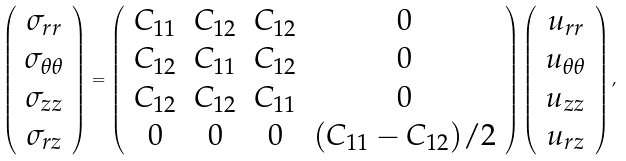<formula> <loc_0><loc_0><loc_500><loc_500>\left ( \begin{array} { c } \sigma _ { r r } \\ \sigma _ { \theta \theta } \\ \sigma _ { z z } \\ \sigma _ { r z } \\ \end{array} \right ) = \left ( \begin{array} { c c c c } C _ { 1 1 } & C _ { 1 2 } & C _ { 1 2 } & 0 \\ C _ { 1 2 } & C _ { 1 1 } & C _ { 1 2 } & 0 \\ C _ { 1 2 } & C _ { 1 2 } & C _ { 1 1 } & 0 \\ 0 & 0 & 0 & ( C _ { 1 1 } - C _ { 1 2 } ) / 2 \\ \end{array} \right ) \left ( \begin{array} { c } u _ { r r } \\ u _ { \theta \theta } \\ u _ { z z } \\ u _ { r z } \\ \end{array} \right ) ,</formula> 